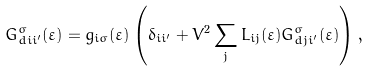<formula> <loc_0><loc_0><loc_500><loc_500>G _ { d i i ^ { \prime } } ^ { \sigma } ( \varepsilon ) = g _ { i \sigma } ( \varepsilon ) \left ( \delta _ { i i ^ { \prime } } + V ^ { 2 } \sum _ { j } L _ { i j } ( \varepsilon ) G _ { d j i ^ { \prime } } ^ { \sigma } ( \varepsilon ) \right ) ,</formula> 